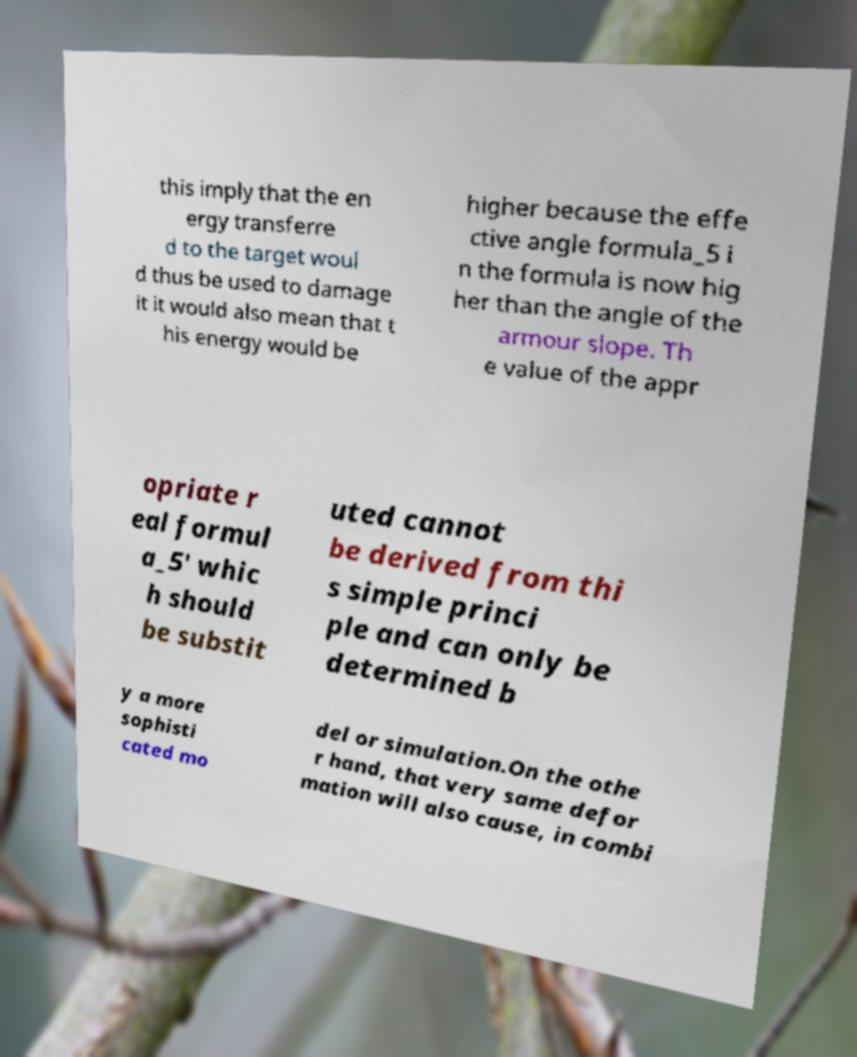For documentation purposes, I need the text within this image transcribed. Could you provide that? this imply that the en ergy transferre d to the target woul d thus be used to damage it it would also mean that t his energy would be higher because the effe ctive angle formula_5 i n the formula is now hig her than the angle of the armour slope. Th e value of the appr opriate r eal formul a_5' whic h should be substit uted cannot be derived from thi s simple princi ple and can only be determined b y a more sophisti cated mo del or simulation.On the othe r hand, that very same defor mation will also cause, in combi 